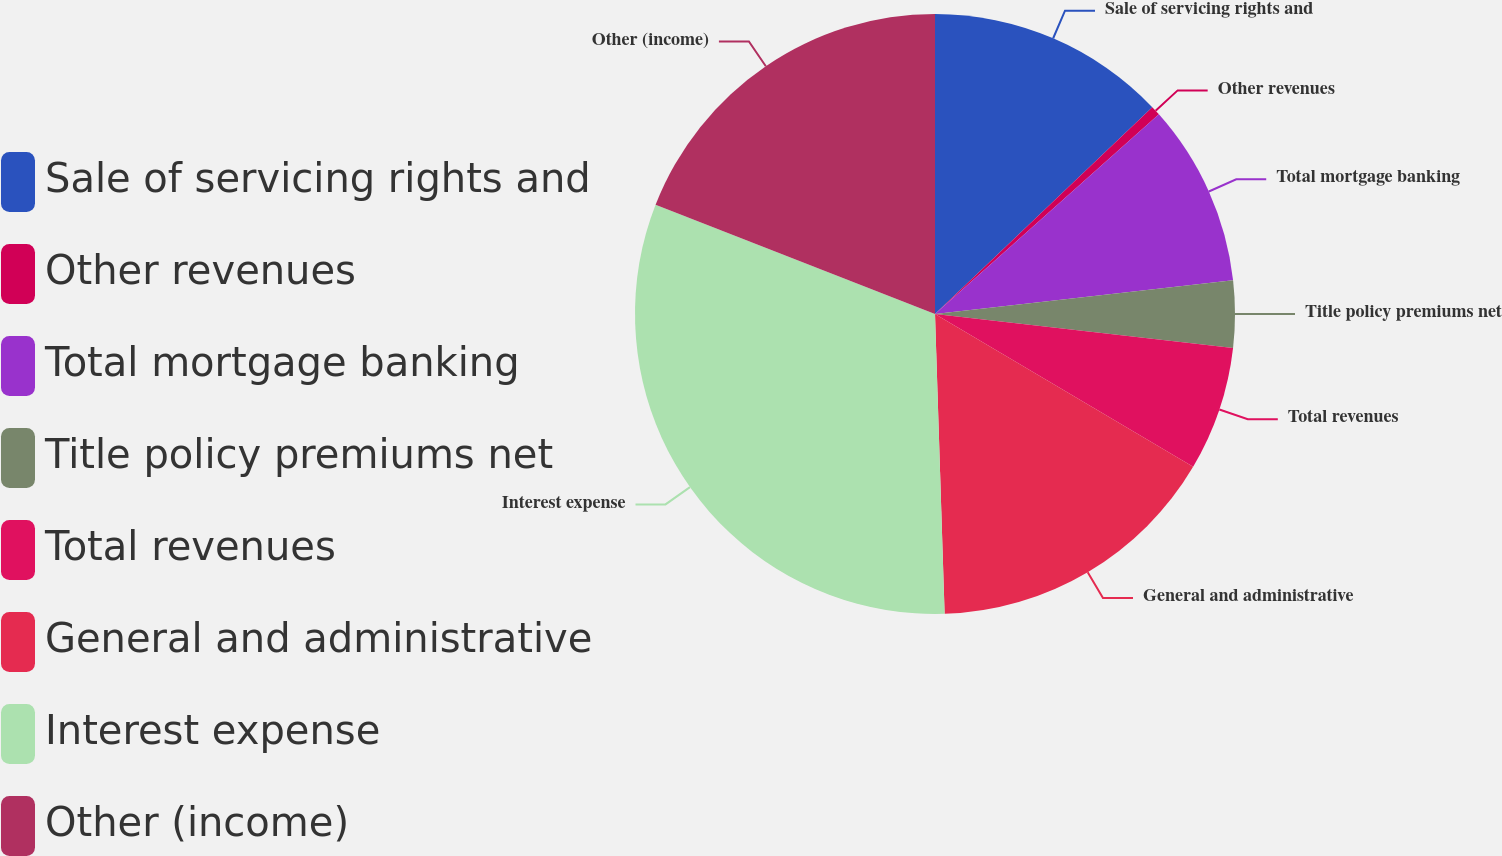<chart> <loc_0><loc_0><loc_500><loc_500><pie_chart><fcel>Sale of servicing rights and<fcel>Other revenues<fcel>Total mortgage banking<fcel>Title policy premiums net<fcel>Total revenues<fcel>General and administrative<fcel>Interest expense<fcel>Other (income)<nl><fcel>12.89%<fcel>0.52%<fcel>9.79%<fcel>3.61%<fcel>6.7%<fcel>15.98%<fcel>31.44%<fcel>19.07%<nl></chart> 